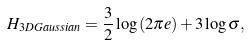<formula> <loc_0><loc_0><loc_500><loc_500>H _ { 3 D G a u s s i a n } = \frac { 3 } { 2 } \log \left ( 2 \pi e \right ) + 3 \log \sigma ,</formula> 